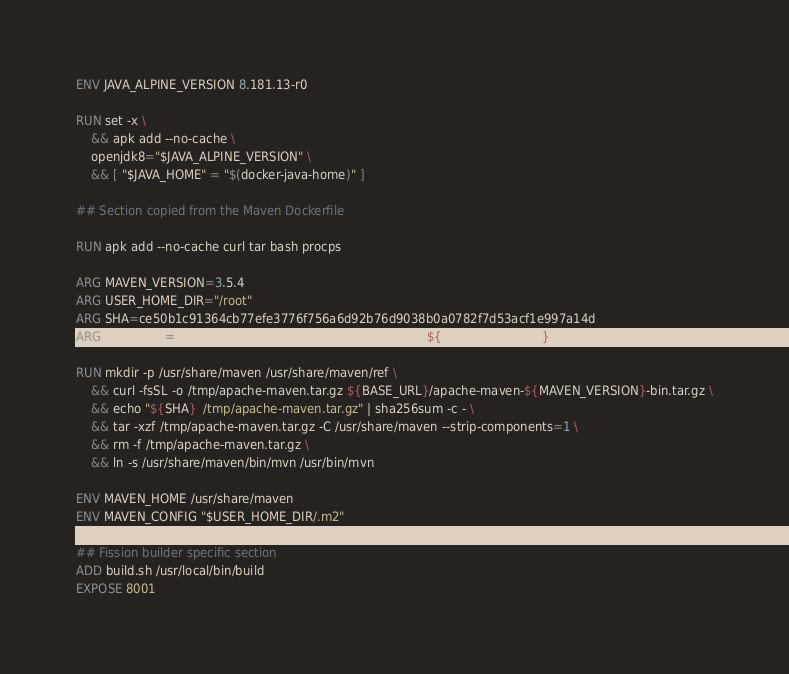Convert code to text. <code><loc_0><loc_0><loc_500><loc_500><_Dockerfile_>ENV JAVA_ALPINE_VERSION 8.181.13-r0

RUN set -x \
    && apk add --no-cache \
    openjdk8="$JAVA_ALPINE_VERSION" \
    && [ "$JAVA_HOME" = "$(docker-java-home)" ]

## Section copied from the Maven Dockerfile

RUN apk add --no-cache curl tar bash procps

ARG MAVEN_VERSION=3.5.4
ARG USER_HOME_DIR="/root"
ARG SHA=ce50b1c91364cb77efe3776f756a6d92b76d9038b0a0782f7d53acf1e997a14d
ARG BASE_URL=https://apache.osuosl.org/maven/maven-3/${MAVEN_VERSION}/binaries

RUN mkdir -p /usr/share/maven /usr/share/maven/ref \
    && curl -fsSL -o /tmp/apache-maven.tar.gz ${BASE_URL}/apache-maven-${MAVEN_VERSION}-bin.tar.gz \
    && echo "${SHA}  /tmp/apache-maven.tar.gz" | sha256sum -c - \
    && tar -xzf /tmp/apache-maven.tar.gz -C /usr/share/maven --strip-components=1 \
    && rm -f /tmp/apache-maven.tar.gz \
    && ln -s /usr/share/maven/bin/mvn /usr/bin/mvn

ENV MAVEN_HOME /usr/share/maven
ENV MAVEN_CONFIG "$USER_HOME_DIR/.m2"

## Fission builder specific section
ADD build.sh /usr/local/bin/build
EXPOSE 8001</code> 